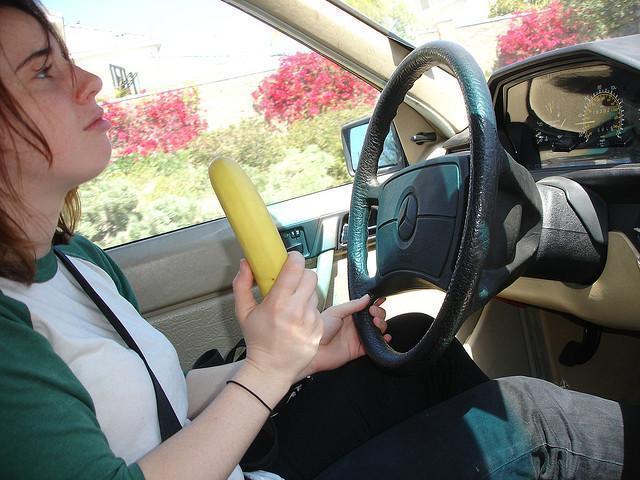Where do bananas originally come from?
Pick the right solution, then justify: 'Answer: answer
Rationale: rationale.'
Options: Americas, asia, india, france. Answer: asia.
Rationale: They are from the southeastern part of the continent, which is tropical. 